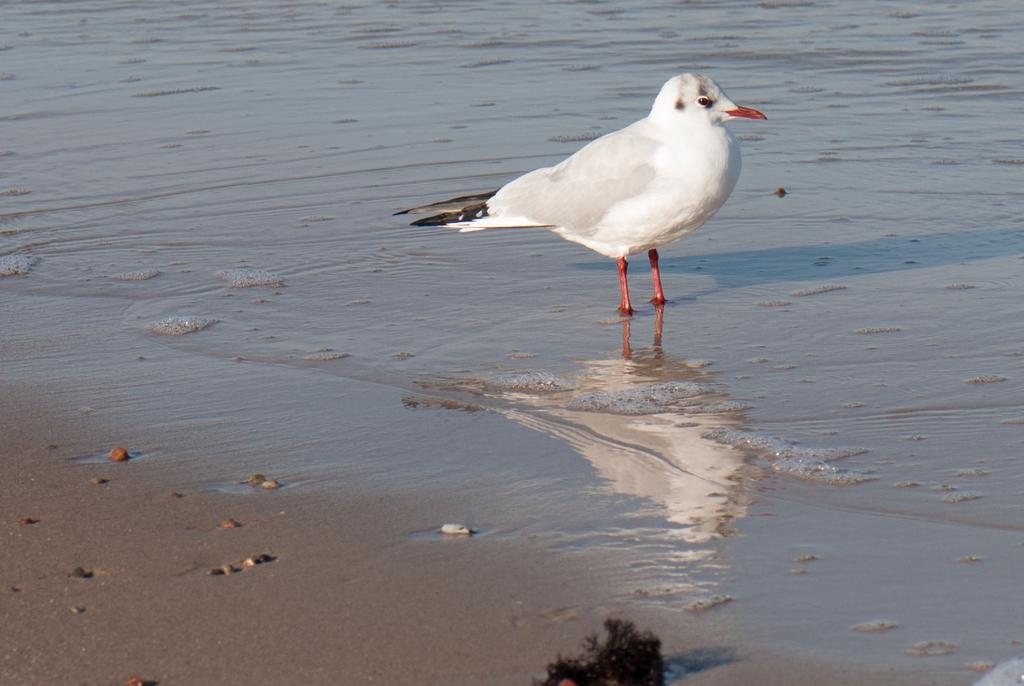What type of animal can be seen in the image? There is a white bird in the image. Where is the bird located in the image? The bird is standing in the water. What can be seen on the path in the image? There are stones on the path in the image. What sense is the bird using to learn about its surroundings in the image? The image does not provide information about the bird's senses or learning abilities, so it cannot be determined from the image. 